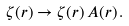<formula> <loc_0><loc_0><loc_500><loc_500>\zeta ( r ) \to \zeta ( r ) \, A ( r ) \, .</formula> 